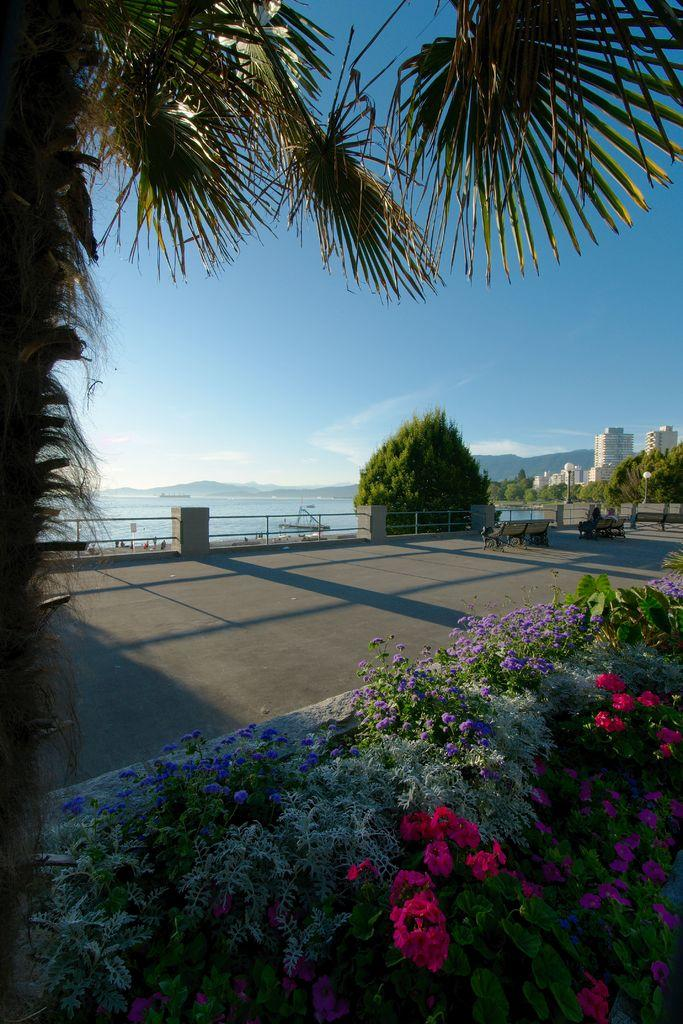What type of plants can be seen in the image? There are plants with flowers in the image. What can be seen in the background of the image? There are buildings, trees, and water visible in the distance. Are there any people present in the image? Yes, there are people in the distance. What is the color of the sky in the image? The sky is blue in the image. What type of list can be seen in the image? There is: There is no list present in the image. What kind of marble is visible in the image? There is no marble visible in the image. 